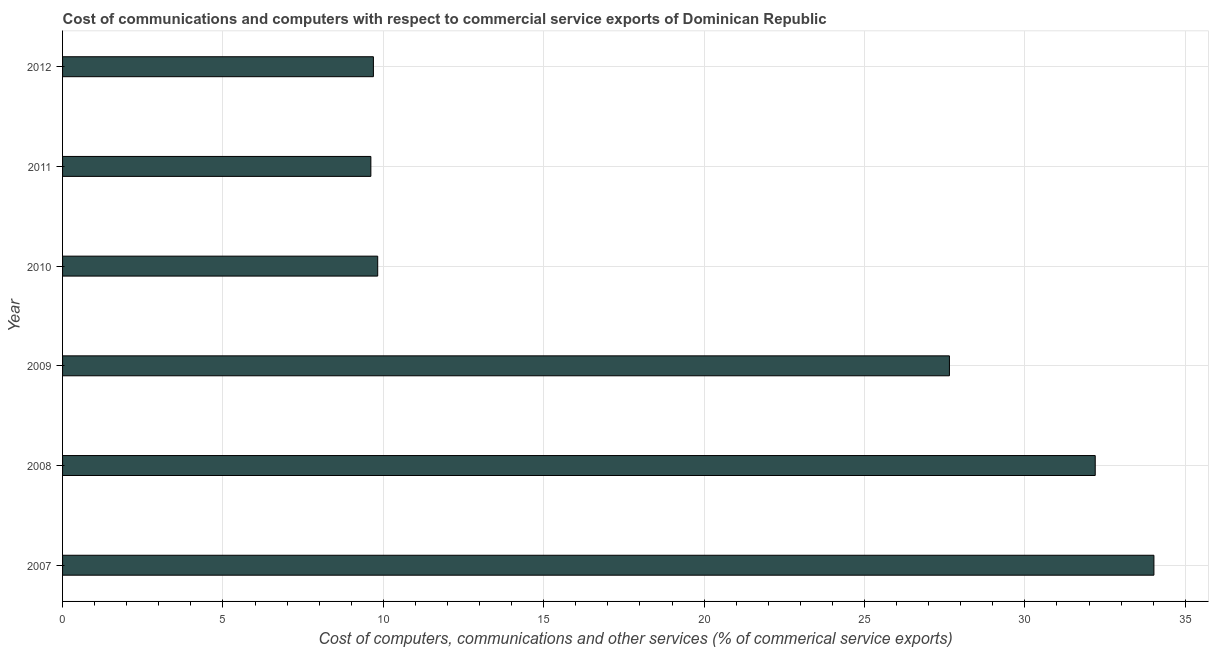Does the graph contain grids?
Keep it short and to the point. Yes. What is the title of the graph?
Provide a succinct answer. Cost of communications and computers with respect to commercial service exports of Dominican Republic. What is the label or title of the X-axis?
Ensure brevity in your answer.  Cost of computers, communications and other services (% of commerical service exports). What is the cost of communications in 2008?
Offer a terse response. 32.19. Across all years, what is the maximum cost of communications?
Give a very brief answer. 34.02. Across all years, what is the minimum  computer and other services?
Your response must be concise. 9.61. In which year was the  computer and other services minimum?
Offer a terse response. 2011. What is the sum of the  computer and other services?
Your response must be concise. 122.99. What is the difference between the cost of communications in 2007 and 2012?
Offer a terse response. 24.33. What is the average  computer and other services per year?
Provide a succinct answer. 20.5. What is the median cost of communications?
Keep it short and to the point. 18.74. In how many years, is the  computer and other services greater than 27 %?
Your answer should be very brief. 3. Do a majority of the years between 2009 and 2010 (inclusive) have  computer and other services greater than 25 %?
Provide a succinct answer. No. What is the ratio of the cost of communications in 2007 to that in 2008?
Ensure brevity in your answer.  1.06. What is the difference between the highest and the second highest  computer and other services?
Your response must be concise. 1.83. Is the sum of the  computer and other services in 2007 and 2008 greater than the maximum  computer and other services across all years?
Your answer should be very brief. Yes. What is the difference between the highest and the lowest cost of communications?
Your response must be concise. 24.41. In how many years, is the  computer and other services greater than the average  computer and other services taken over all years?
Provide a succinct answer. 3. Are all the bars in the graph horizontal?
Provide a short and direct response. Yes. Are the values on the major ticks of X-axis written in scientific E-notation?
Keep it short and to the point. No. What is the Cost of computers, communications and other services (% of commerical service exports) of 2007?
Keep it short and to the point. 34.02. What is the Cost of computers, communications and other services (% of commerical service exports) in 2008?
Your response must be concise. 32.19. What is the Cost of computers, communications and other services (% of commerical service exports) in 2009?
Give a very brief answer. 27.65. What is the Cost of computers, communications and other services (% of commerical service exports) in 2010?
Make the answer very short. 9.82. What is the Cost of computers, communications and other services (% of commerical service exports) in 2011?
Provide a succinct answer. 9.61. What is the Cost of computers, communications and other services (% of commerical service exports) of 2012?
Provide a succinct answer. 9.69. What is the difference between the Cost of computers, communications and other services (% of commerical service exports) in 2007 and 2008?
Provide a succinct answer. 1.83. What is the difference between the Cost of computers, communications and other services (% of commerical service exports) in 2007 and 2009?
Give a very brief answer. 6.37. What is the difference between the Cost of computers, communications and other services (% of commerical service exports) in 2007 and 2010?
Provide a short and direct response. 24.2. What is the difference between the Cost of computers, communications and other services (% of commerical service exports) in 2007 and 2011?
Offer a very short reply. 24.41. What is the difference between the Cost of computers, communications and other services (% of commerical service exports) in 2007 and 2012?
Your answer should be compact. 24.33. What is the difference between the Cost of computers, communications and other services (% of commerical service exports) in 2008 and 2009?
Your answer should be compact. 4.55. What is the difference between the Cost of computers, communications and other services (% of commerical service exports) in 2008 and 2010?
Give a very brief answer. 22.37. What is the difference between the Cost of computers, communications and other services (% of commerical service exports) in 2008 and 2011?
Offer a very short reply. 22.58. What is the difference between the Cost of computers, communications and other services (% of commerical service exports) in 2008 and 2012?
Ensure brevity in your answer.  22.5. What is the difference between the Cost of computers, communications and other services (% of commerical service exports) in 2009 and 2010?
Your answer should be very brief. 17.82. What is the difference between the Cost of computers, communications and other services (% of commerical service exports) in 2009 and 2011?
Offer a terse response. 18.04. What is the difference between the Cost of computers, communications and other services (% of commerical service exports) in 2009 and 2012?
Your answer should be compact. 17.96. What is the difference between the Cost of computers, communications and other services (% of commerical service exports) in 2010 and 2011?
Offer a terse response. 0.21. What is the difference between the Cost of computers, communications and other services (% of commerical service exports) in 2010 and 2012?
Your response must be concise. 0.13. What is the difference between the Cost of computers, communications and other services (% of commerical service exports) in 2011 and 2012?
Provide a succinct answer. -0.08. What is the ratio of the Cost of computers, communications and other services (% of commerical service exports) in 2007 to that in 2008?
Make the answer very short. 1.06. What is the ratio of the Cost of computers, communications and other services (% of commerical service exports) in 2007 to that in 2009?
Provide a succinct answer. 1.23. What is the ratio of the Cost of computers, communications and other services (% of commerical service exports) in 2007 to that in 2010?
Give a very brief answer. 3.46. What is the ratio of the Cost of computers, communications and other services (% of commerical service exports) in 2007 to that in 2011?
Make the answer very short. 3.54. What is the ratio of the Cost of computers, communications and other services (% of commerical service exports) in 2007 to that in 2012?
Your response must be concise. 3.51. What is the ratio of the Cost of computers, communications and other services (% of commerical service exports) in 2008 to that in 2009?
Provide a succinct answer. 1.16. What is the ratio of the Cost of computers, communications and other services (% of commerical service exports) in 2008 to that in 2010?
Your answer should be very brief. 3.28. What is the ratio of the Cost of computers, communications and other services (% of commerical service exports) in 2008 to that in 2011?
Your answer should be compact. 3.35. What is the ratio of the Cost of computers, communications and other services (% of commerical service exports) in 2008 to that in 2012?
Make the answer very short. 3.32. What is the ratio of the Cost of computers, communications and other services (% of commerical service exports) in 2009 to that in 2010?
Provide a short and direct response. 2.81. What is the ratio of the Cost of computers, communications and other services (% of commerical service exports) in 2009 to that in 2011?
Your answer should be compact. 2.88. What is the ratio of the Cost of computers, communications and other services (% of commerical service exports) in 2009 to that in 2012?
Your response must be concise. 2.85. What is the ratio of the Cost of computers, communications and other services (% of commerical service exports) in 2010 to that in 2011?
Provide a short and direct response. 1.02. What is the ratio of the Cost of computers, communications and other services (% of commerical service exports) in 2011 to that in 2012?
Provide a succinct answer. 0.99. 